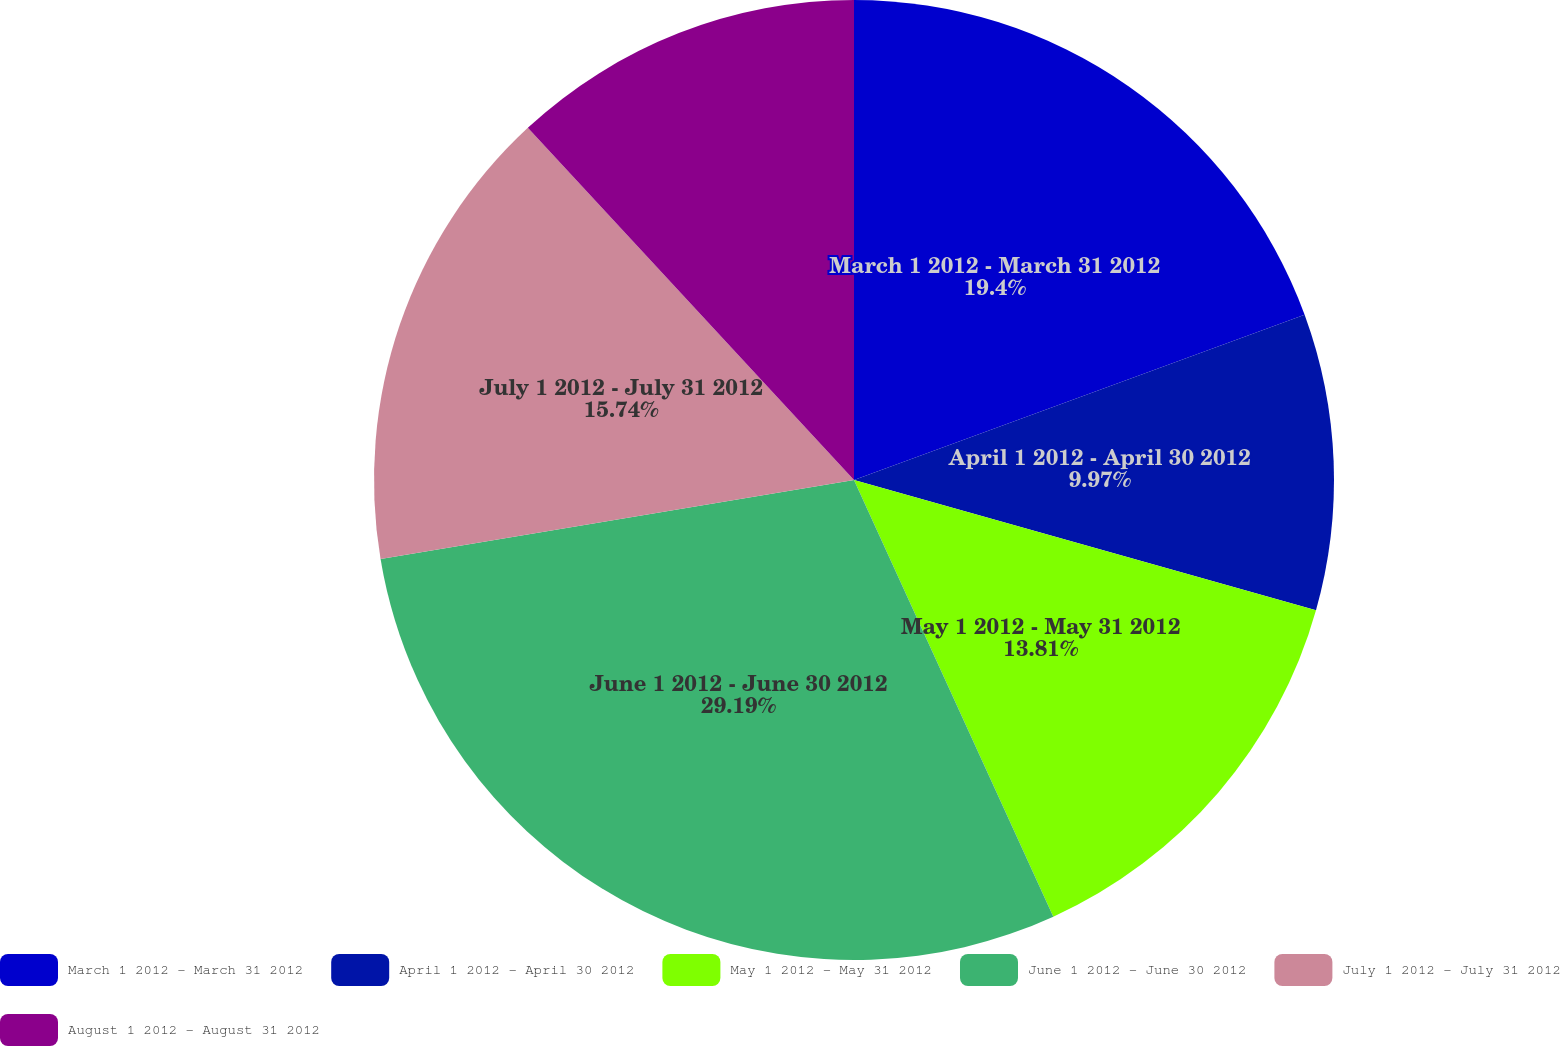Convert chart. <chart><loc_0><loc_0><loc_500><loc_500><pie_chart><fcel>March 1 2012 - March 31 2012<fcel>April 1 2012 - April 30 2012<fcel>May 1 2012 - May 31 2012<fcel>June 1 2012 - June 30 2012<fcel>July 1 2012 - July 31 2012<fcel>August 1 2012 - August 31 2012<nl><fcel>19.4%<fcel>9.97%<fcel>13.81%<fcel>29.18%<fcel>15.74%<fcel>11.89%<nl></chart> 